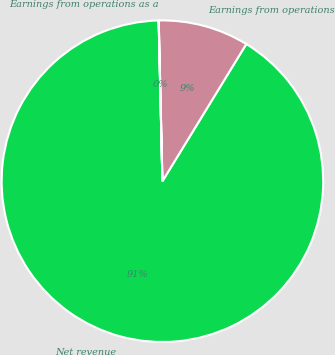Convert chart to OTSL. <chart><loc_0><loc_0><loc_500><loc_500><pie_chart><fcel>Net revenue<fcel>Earnings from operations<fcel>Earnings from operations as a<nl><fcel>90.89%<fcel>9.1%<fcel>0.01%<nl></chart> 